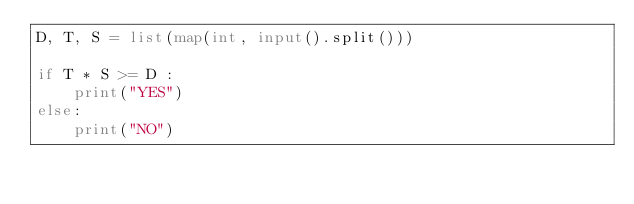<code> <loc_0><loc_0><loc_500><loc_500><_Python_>D, T, S = list(map(int, input().split()))

if T * S >= D :
    print("YES")
else:
    print("NO")</code> 